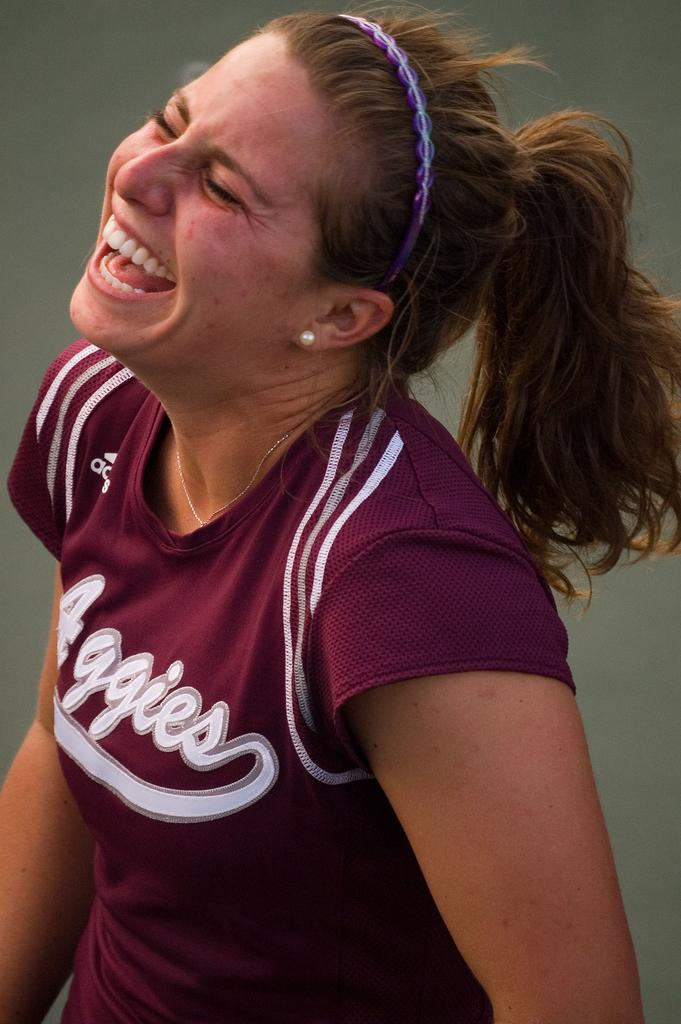<image>
Offer a succinct explanation of the picture presented. A girl is laughing and wearing a maroon shirt that says Aggies. 